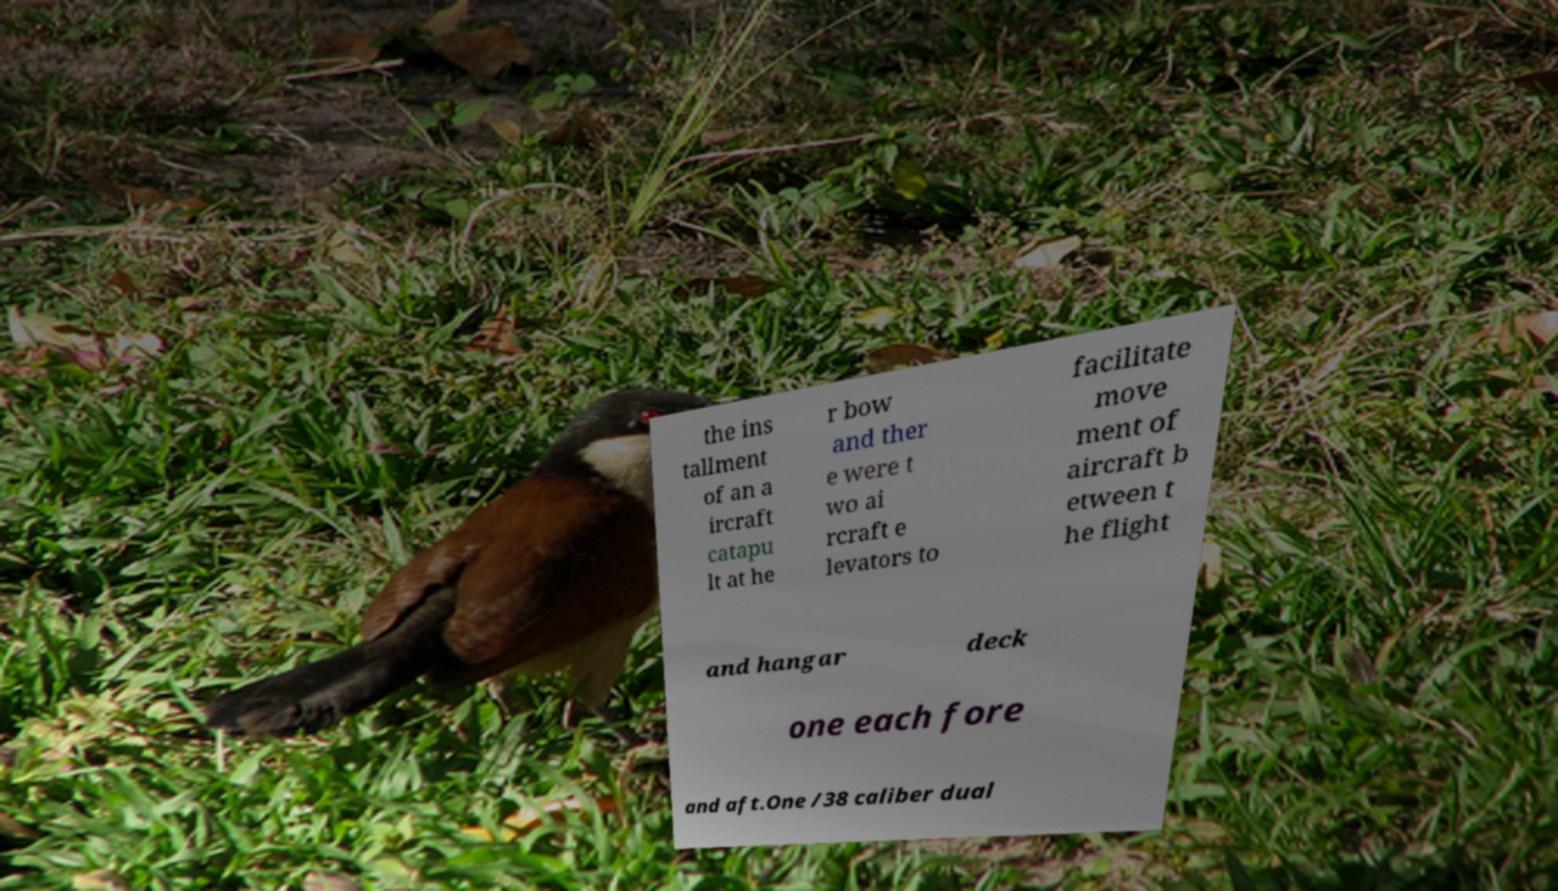Could you extract and type out the text from this image? the ins tallment of an a ircraft catapu lt at he r bow and ther e were t wo ai rcraft e levators to facilitate move ment of aircraft b etween t he flight and hangar deck one each fore and aft.One /38 caliber dual 